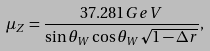<formula> <loc_0><loc_0><loc_500><loc_500>\mu _ { Z } = { \frac { 3 7 . 2 8 1 G e V } { \sin \theta _ { W } \cos \theta _ { W } \sqrt { 1 - \Delta r } } } ,</formula> 